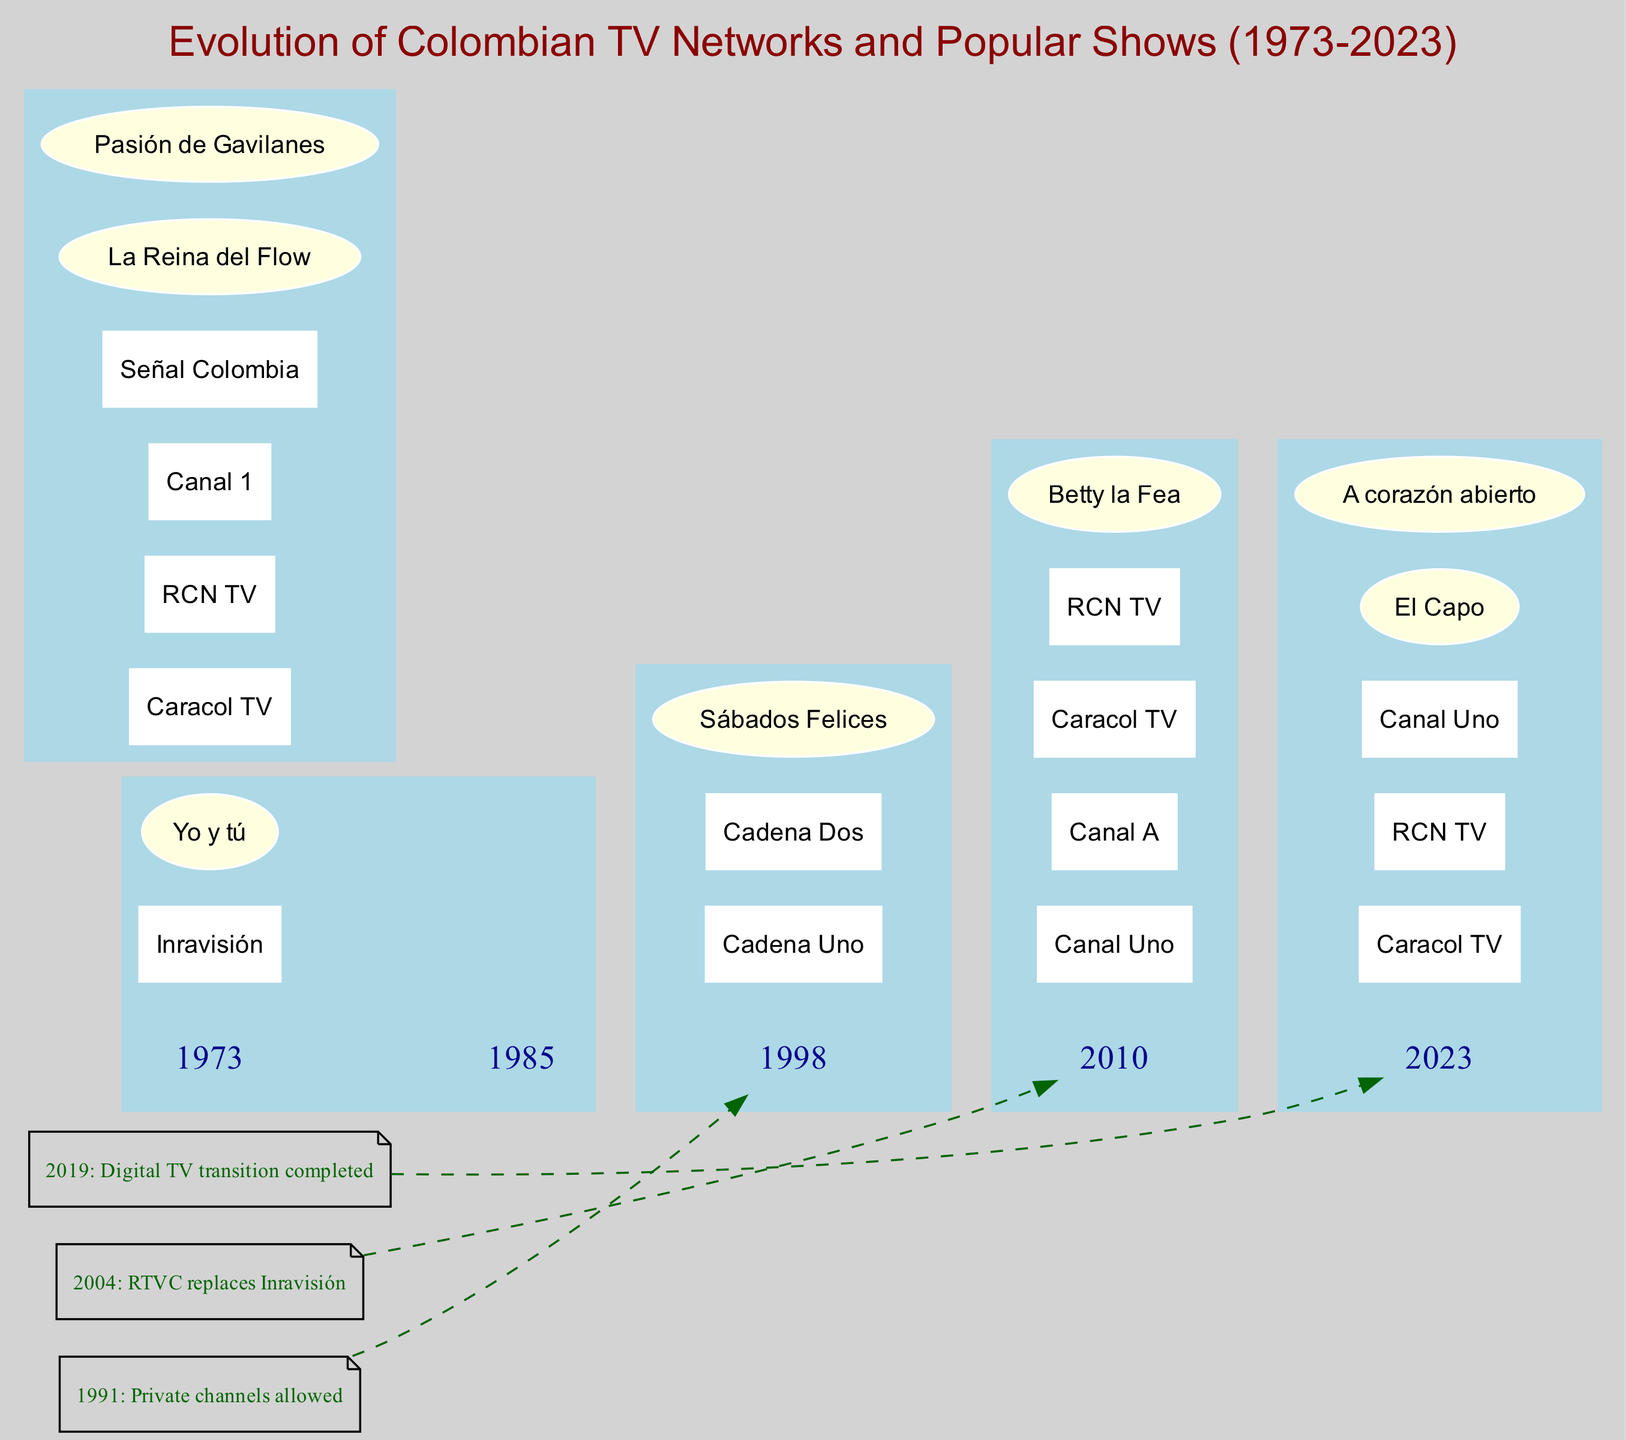What year did private channels become allowed? The diagram includes a key event labeled "1991: Private channels allowed." From this, we can directly extract the year mentioned in that key event.
Answer: 1991 Which network appeared for the first time in 1998? In the 1998 section of the diagram, the networks listed include "Canal Uno," "Canal A," "Caracol TV," and "RCN TV." The question is asking specifically for the first instance in the timeline, and the first listed network is "Canal Uno."
Answer: Canal Uno What show was popular in 2010? In the 2010 section of the diagram, the shows listed are "El Capo" and "A corazón abierto." The question asks for any show during that year, and "El Capo" is one of the two listed.
Answer: El Capo How many networks were present in 2023? Referring to the 2023 section of the diagram, the networks indicated are "Caracol TV," "RCN TV," "Canal 1," and "Señal Colombia." Counting them gives a total of four networks present in that year.
Answer: 4 In which year did "Yo y tú" first air? The diagram shows that the show "Yo y tú" is listed under the year 1973. Therefore, the year when this show first aired can be directly taken from the timeline.
Answer: 1973 What color represents the nodes for shows in the diagram? In the diagram, the shows are represented as nodes with an ellipse shape and a fill color of "lightyellow." This specification for shows is explicitly defined in the diagram's structure.
Answer: lightyellow Which event corresponds to the transition to digital TV? The diagram lists a key event as "2019: Digital TV transition completed." This event denotes the completion of the transition, and the relevant year is present alongside the description.
Answer: 2019 List the networks present in 2010. Under the 2010 section, the networks mentioned are "Caracol TV," "RCN TV," and "Canal Uno." These are specifically noted for that year in the diagram.
Answer: Caracol TV, RCN TV, Canal Uno How is the relationship between the events and the years displayed? The diagram connects key events to years using dashed lines, showing a non-direct connection, which commonly indicates that the event impacts the timeline of the networks and shows but doesn't change the year itself directly.
Answer: Dashed lines 